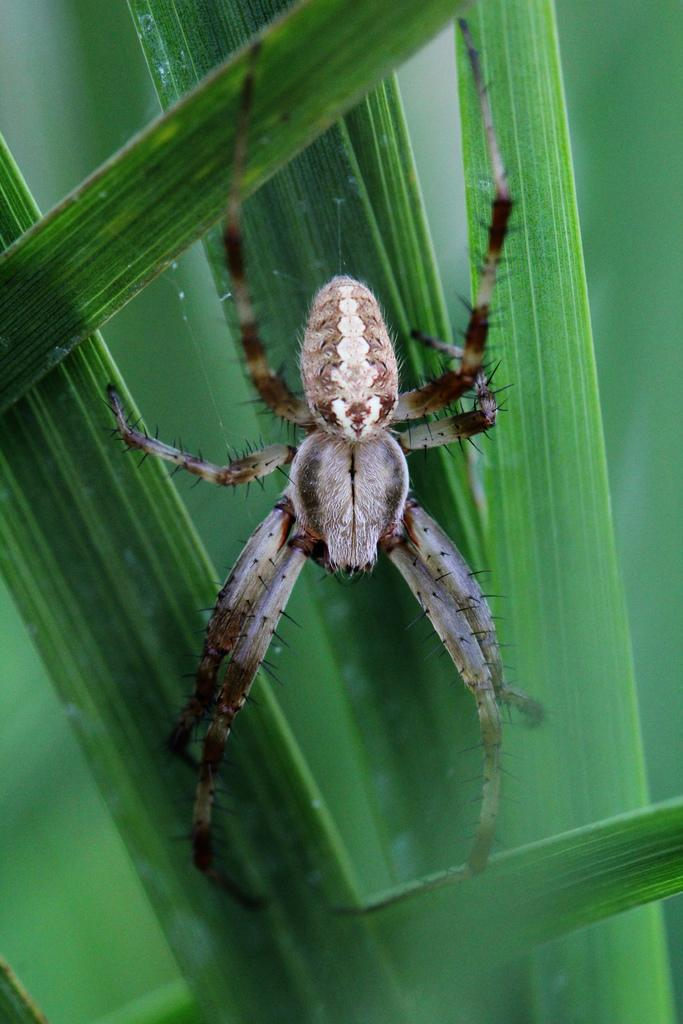What type of creature can be seen in the picture? There is an insect in the picture. What is the color and texture of the grass in the picture? The grass in the picture is green and has a natural texture. What advice does the father give to the insect in the picture? There is no father or any dialogue present in the image, so it is not possible to determine any advice given. 